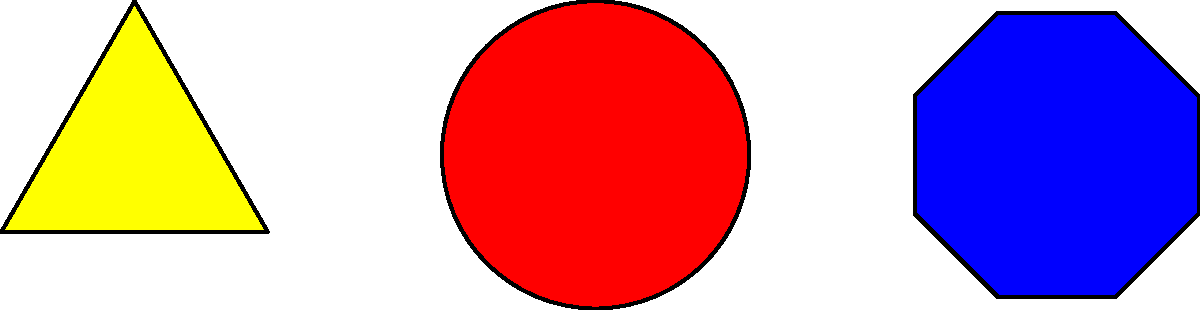Which of the following safety actions does the blue octagonal sign in the image typically indicate on a construction site? To interpret this construction site safety sign, let's analyze the image step-by-step:

1. The image shows three different shapes: a yellow triangle, a red circle, and a blue octagon.

2. Each shape has a specific meaning in safety signage:
   - Yellow triangle: Warning
   - Red circle: Prohibition
   - Blue octagon: Mandatory action

3. The blue octagonal sign is similar to a traffic stop sign, which is universally recognized.

4. In construction site safety, blue signs generally indicate mandatory actions or behaviors.

5. The word "STOP" is clearly visible inside the blue octagon, which reinforces its meaning.

6. On construction sites, a blue octagonal sign with "STOP" typically indicates that workers must stop and not proceed further without authorization or specific safety checks.

Therefore, the blue octagonal sign in the image indicates a mandatory stop action for safety reasons on the construction site.
Answer: Mandatory stop 